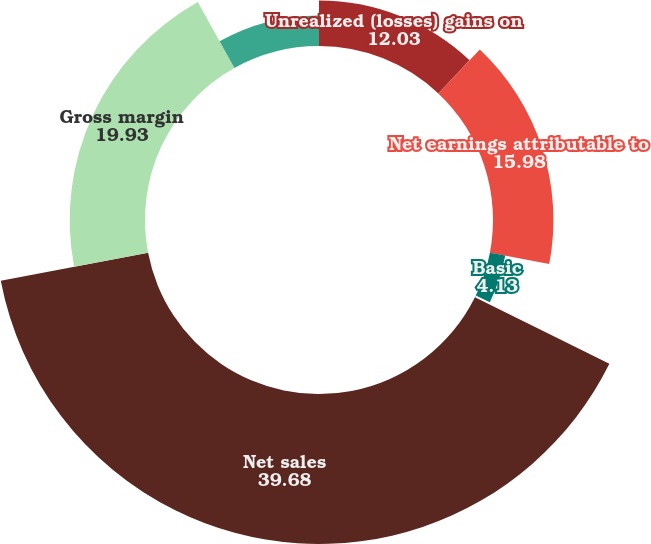Convert chart. <chart><loc_0><loc_0><loc_500><loc_500><pie_chart><fcel>Unrealized (losses) gains on<fcel>Net earnings attributable to<fcel>Basic<fcel>Diluted<fcel>Net sales<fcel>Gross margin<fcel>Unrealized gains (losses) on<nl><fcel>12.03%<fcel>15.98%<fcel>4.13%<fcel>0.18%<fcel>39.68%<fcel>19.93%<fcel>8.08%<nl></chart> 